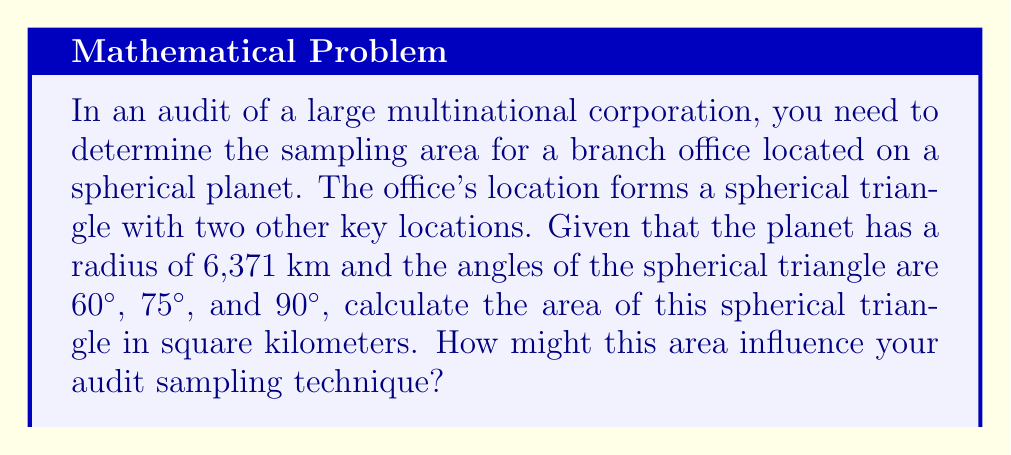Solve this math problem. To solve this problem, we'll use the principles of spherical geometry and apply them to audit sampling. Let's break it down step-by-step:

1) In spherical geometry, the area of a triangle is given by the formula:

   $$A = R^2 * E$$

   Where A is the area, R is the radius of the sphere, and E is the spherical excess in radians.

2) The spherical excess E is calculated as:

   $$E = \alpha + \beta + \gamma - \pi$$

   Where α, β, and γ are the angles of the spherical triangle in radians.

3) Convert the given angles from degrees to radians:
   
   $$60° = \frac{\pi}{3} \text{ rad}$$
   $$75° = \frac{5\pi}{12} \text{ rad}$$
   $$90° = \frac{\pi}{2} \text{ rad}$$

4) Calculate the spherical excess:

   $$E = \frac{\pi}{3} + \frac{5\pi}{12} + \frac{\pi}{2} - \pi = \frac{\pi}{4} \text{ rad}$$

5) Now, substitute the values into the area formula:

   $$A = (6,371 \text{ km})^2 * \frac{\pi}{4} = 31,865,515.5 \text{ km}^2$$

6) This area represents approximately 6.25% of the planet's surface area.

7) In terms of audit sampling, this large area suggests:
   - A potentially diverse and scattered population
   - The need for stratified sampling to ensure representation across the entire area
   - Consideration of geographical factors in risk assessment and sample selection
   - Possible use of cluster sampling for efficiency in remote or hard-to-reach areas

8) The auditor might consider:
   - Increasing sample size to account for the large area and potential variability
   - Using geospatial analysis tools to visualize and analyze the distribution of samples
   - Incorporating travel time and costs into the sampling strategy
   - Employing remote auditing techniques for distant locations within the triangle
Answer: 31,865,515.5 km²; Suggests need for stratified sampling, increased sample size, and geospatial analysis in audit approach. 